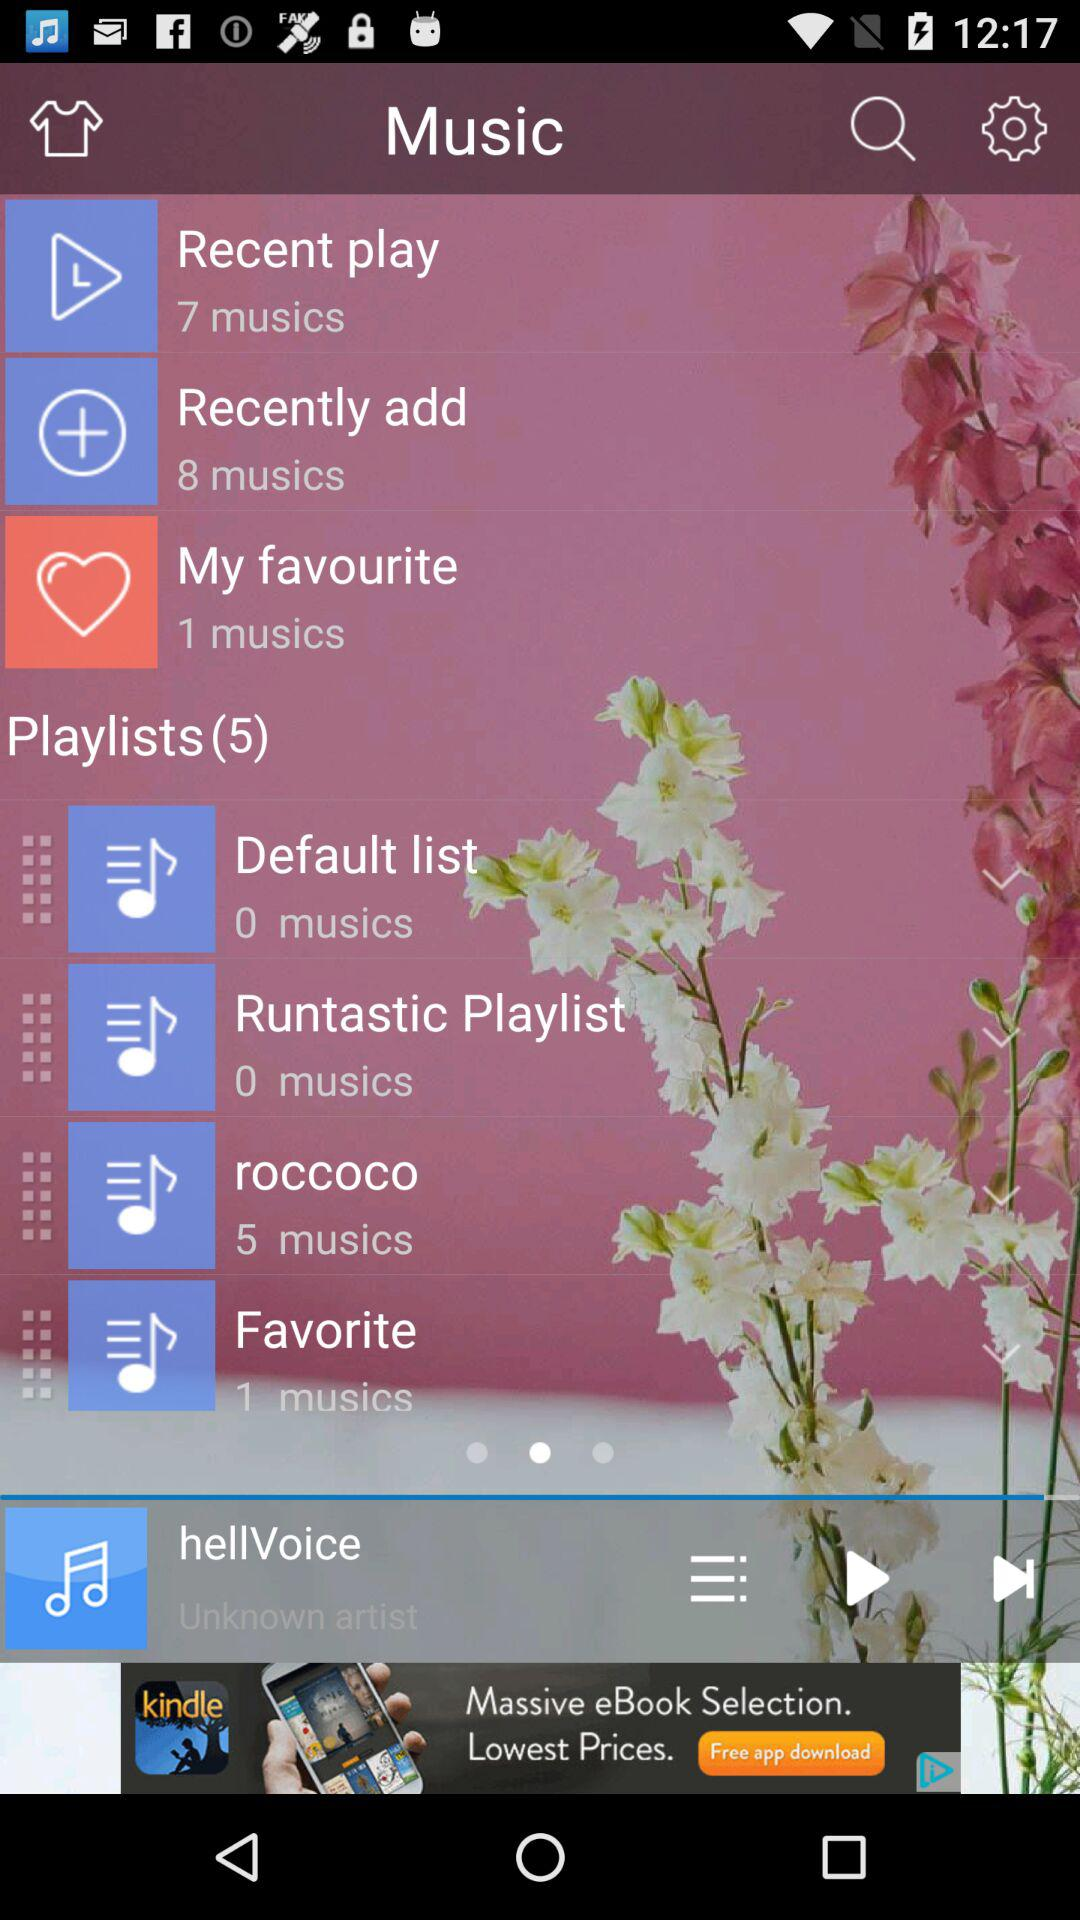How many musics is in "My favourite" list? There is 1 music. 